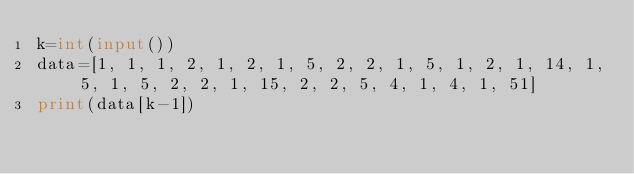Convert code to text. <code><loc_0><loc_0><loc_500><loc_500><_Python_>k=int(input())
data=[1, 1, 1, 2, 1, 2, 1, 5, 2, 2, 1, 5, 1, 2, 1, 14, 1, 5, 1, 5, 2, 2, 1, 15, 2, 2, 5, 4, 1, 4, 1, 51]
print(data[k-1])</code> 